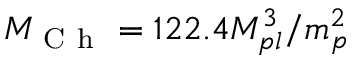<formula> <loc_0><loc_0><loc_500><loc_500>M _ { C h } = 1 2 2 . 4 M _ { p l } ^ { 3 } / m _ { p } ^ { 2 }</formula> 